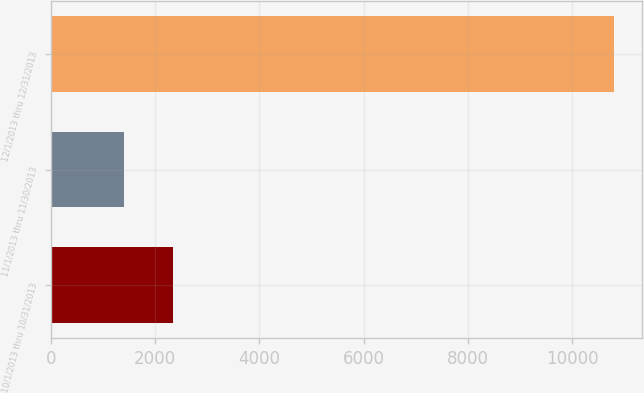Convert chart. <chart><loc_0><loc_0><loc_500><loc_500><bar_chart><fcel>10/1/2013 thru 10/31/2013<fcel>11/1/2013 thru 11/30/2013<fcel>12/1/2013 thru 12/31/2013<nl><fcel>2340.1<fcel>1399<fcel>10810<nl></chart> 